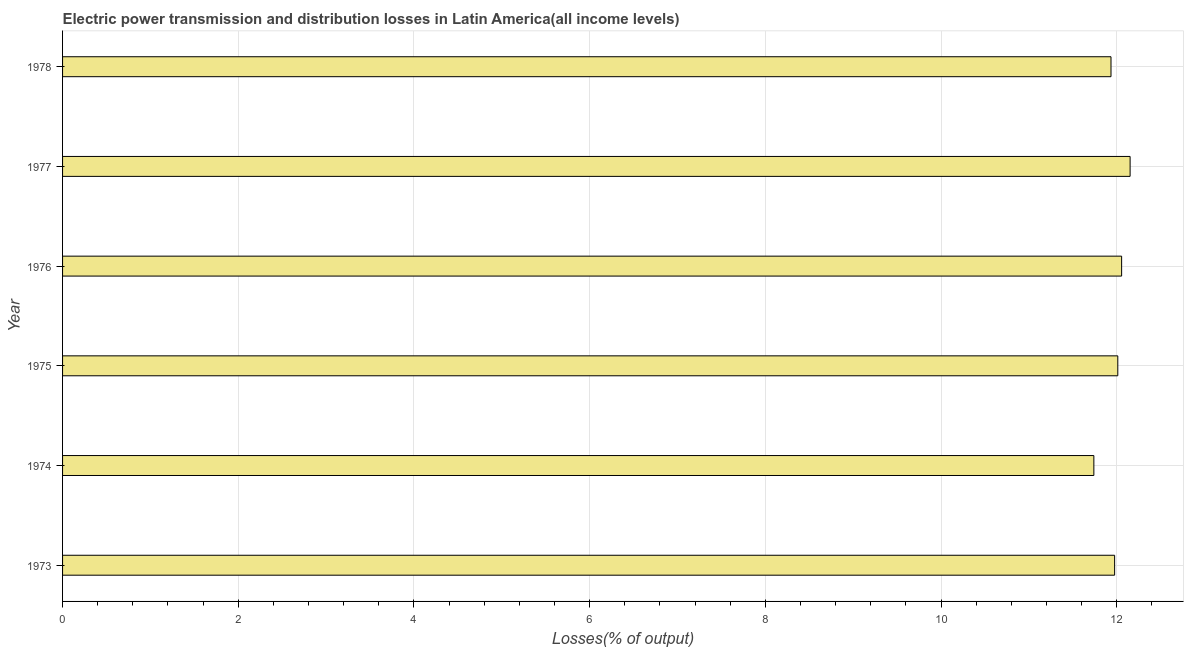Does the graph contain any zero values?
Ensure brevity in your answer.  No. What is the title of the graph?
Offer a terse response. Electric power transmission and distribution losses in Latin America(all income levels). What is the label or title of the X-axis?
Make the answer very short. Losses(% of output). What is the electric power transmission and distribution losses in 1977?
Offer a terse response. 12.15. Across all years, what is the maximum electric power transmission and distribution losses?
Ensure brevity in your answer.  12.15. Across all years, what is the minimum electric power transmission and distribution losses?
Your response must be concise. 11.74. In which year was the electric power transmission and distribution losses maximum?
Your response must be concise. 1977. In which year was the electric power transmission and distribution losses minimum?
Your answer should be compact. 1974. What is the sum of the electric power transmission and distribution losses?
Provide a short and direct response. 71.87. What is the difference between the electric power transmission and distribution losses in 1973 and 1976?
Keep it short and to the point. -0.08. What is the average electric power transmission and distribution losses per year?
Keep it short and to the point. 11.98. What is the median electric power transmission and distribution losses?
Provide a short and direct response. 11.99. In how many years, is the electric power transmission and distribution losses greater than 7.6 %?
Your answer should be compact. 6. What is the ratio of the electric power transmission and distribution losses in 1975 to that in 1978?
Offer a very short reply. 1.01. Is the electric power transmission and distribution losses in 1975 less than that in 1976?
Provide a short and direct response. Yes. What is the difference between the highest and the second highest electric power transmission and distribution losses?
Your answer should be very brief. 0.1. What is the difference between the highest and the lowest electric power transmission and distribution losses?
Your response must be concise. 0.41. In how many years, is the electric power transmission and distribution losses greater than the average electric power transmission and distribution losses taken over all years?
Your response must be concise. 3. How many bars are there?
Keep it short and to the point. 6. How many years are there in the graph?
Give a very brief answer. 6. What is the difference between two consecutive major ticks on the X-axis?
Your response must be concise. 2. Are the values on the major ticks of X-axis written in scientific E-notation?
Your response must be concise. No. What is the Losses(% of output) of 1973?
Give a very brief answer. 11.98. What is the Losses(% of output) in 1974?
Your answer should be compact. 11.74. What is the Losses(% of output) in 1975?
Provide a short and direct response. 12.01. What is the Losses(% of output) of 1976?
Your answer should be compact. 12.06. What is the Losses(% of output) of 1977?
Make the answer very short. 12.15. What is the Losses(% of output) of 1978?
Make the answer very short. 11.94. What is the difference between the Losses(% of output) in 1973 and 1974?
Give a very brief answer. 0.24. What is the difference between the Losses(% of output) in 1973 and 1975?
Your answer should be compact. -0.04. What is the difference between the Losses(% of output) in 1973 and 1976?
Provide a succinct answer. -0.08. What is the difference between the Losses(% of output) in 1973 and 1977?
Ensure brevity in your answer.  -0.18. What is the difference between the Losses(% of output) in 1973 and 1978?
Your answer should be compact. 0.04. What is the difference between the Losses(% of output) in 1974 and 1975?
Your answer should be compact. -0.27. What is the difference between the Losses(% of output) in 1974 and 1976?
Your response must be concise. -0.32. What is the difference between the Losses(% of output) in 1974 and 1977?
Your answer should be compact. -0.41. What is the difference between the Losses(% of output) in 1974 and 1978?
Offer a very short reply. -0.2. What is the difference between the Losses(% of output) in 1975 and 1976?
Your response must be concise. -0.04. What is the difference between the Losses(% of output) in 1975 and 1977?
Keep it short and to the point. -0.14. What is the difference between the Losses(% of output) in 1975 and 1978?
Offer a very short reply. 0.08. What is the difference between the Losses(% of output) in 1976 and 1977?
Offer a terse response. -0.1. What is the difference between the Losses(% of output) in 1976 and 1978?
Make the answer very short. 0.12. What is the difference between the Losses(% of output) in 1977 and 1978?
Offer a very short reply. 0.22. What is the ratio of the Losses(% of output) in 1973 to that in 1974?
Your answer should be compact. 1.02. What is the ratio of the Losses(% of output) in 1973 to that in 1977?
Provide a short and direct response. 0.98. What is the ratio of the Losses(% of output) in 1973 to that in 1978?
Provide a succinct answer. 1. What is the ratio of the Losses(% of output) in 1974 to that in 1975?
Make the answer very short. 0.98. What is the ratio of the Losses(% of output) in 1974 to that in 1976?
Make the answer very short. 0.97. What is the ratio of the Losses(% of output) in 1974 to that in 1978?
Keep it short and to the point. 0.98. What is the ratio of the Losses(% of output) in 1976 to that in 1977?
Make the answer very short. 0.99. What is the ratio of the Losses(% of output) in 1976 to that in 1978?
Your answer should be very brief. 1.01. What is the ratio of the Losses(% of output) in 1977 to that in 1978?
Offer a terse response. 1.02. 